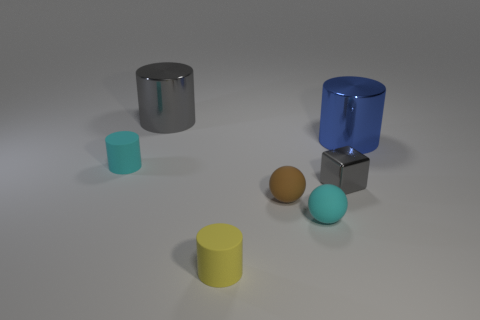Is the large gray thing the same shape as the tiny yellow matte thing?
Make the answer very short. Yes. There is a gray metallic cylinder; what number of large shiny cylinders are right of it?
Your response must be concise. 1. There is a rubber cylinder that is on the left side of the gray cylinder; is its size the same as the small brown sphere?
Offer a very short reply. Yes. There is another large thing that is the same shape as the big gray thing; what color is it?
Give a very brief answer. Blue. Is there any other thing that has the same shape as the small gray metal thing?
Your response must be concise. No. There is a tiny cyan rubber thing that is in front of the brown object; what shape is it?
Ensure brevity in your answer.  Sphere. How many other blue objects are the same shape as the large blue object?
Keep it short and to the point. 0. There is a small matte object that is to the left of the tiny yellow cylinder; does it have the same color as the object to the right of the block?
Keep it short and to the point. No. How many things are either large shiny objects or cyan rubber objects?
Make the answer very short. 4. What number of spheres have the same material as the cyan cylinder?
Make the answer very short. 2. 